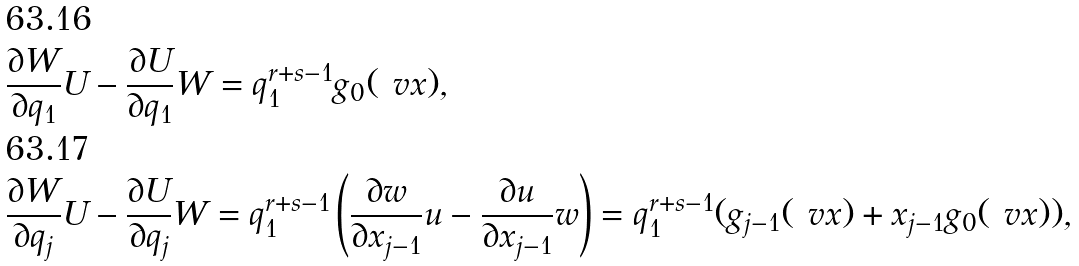Convert formula to latex. <formula><loc_0><loc_0><loc_500><loc_500>& \frac { \partial W } { \partial q _ { 1 } } U - \frac { \partial U } { \partial q _ { 1 } } W = q _ { 1 } ^ { r + s - 1 } g _ { 0 } ( \ v x ) , \\ & \frac { \partial W } { \partial q _ { j } } U - \frac { \partial U } { \partial q _ { j } } W = q _ { 1 } ^ { r + s - 1 } \left ( \frac { \partial w } { \partial x _ { j - 1 } } u - \frac { \partial u } { \partial x _ { j - 1 } } w \right ) = q _ { 1 } ^ { r + s - 1 } ( g _ { j - 1 } ( \ v x ) + x _ { j - 1 } g _ { 0 } ( \ v x ) ) ,</formula> 